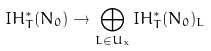<formula> <loc_0><loc_0><loc_500><loc_500>I H ^ { * } _ { T } ( N _ { 0 } ) \to \bigoplus _ { L \in U _ { x } } I H ^ { * } _ { T } ( N _ { 0 } ) _ { L }</formula> 